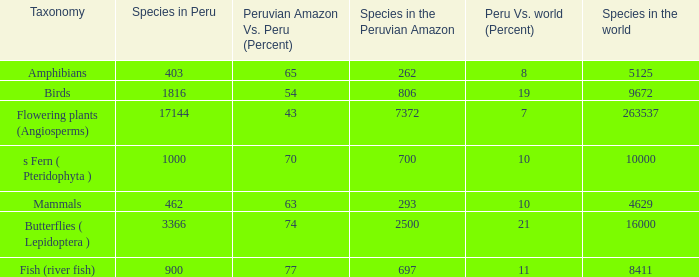What's the total number of species in the peruvian amazon with 8411 species in the world  1.0. 